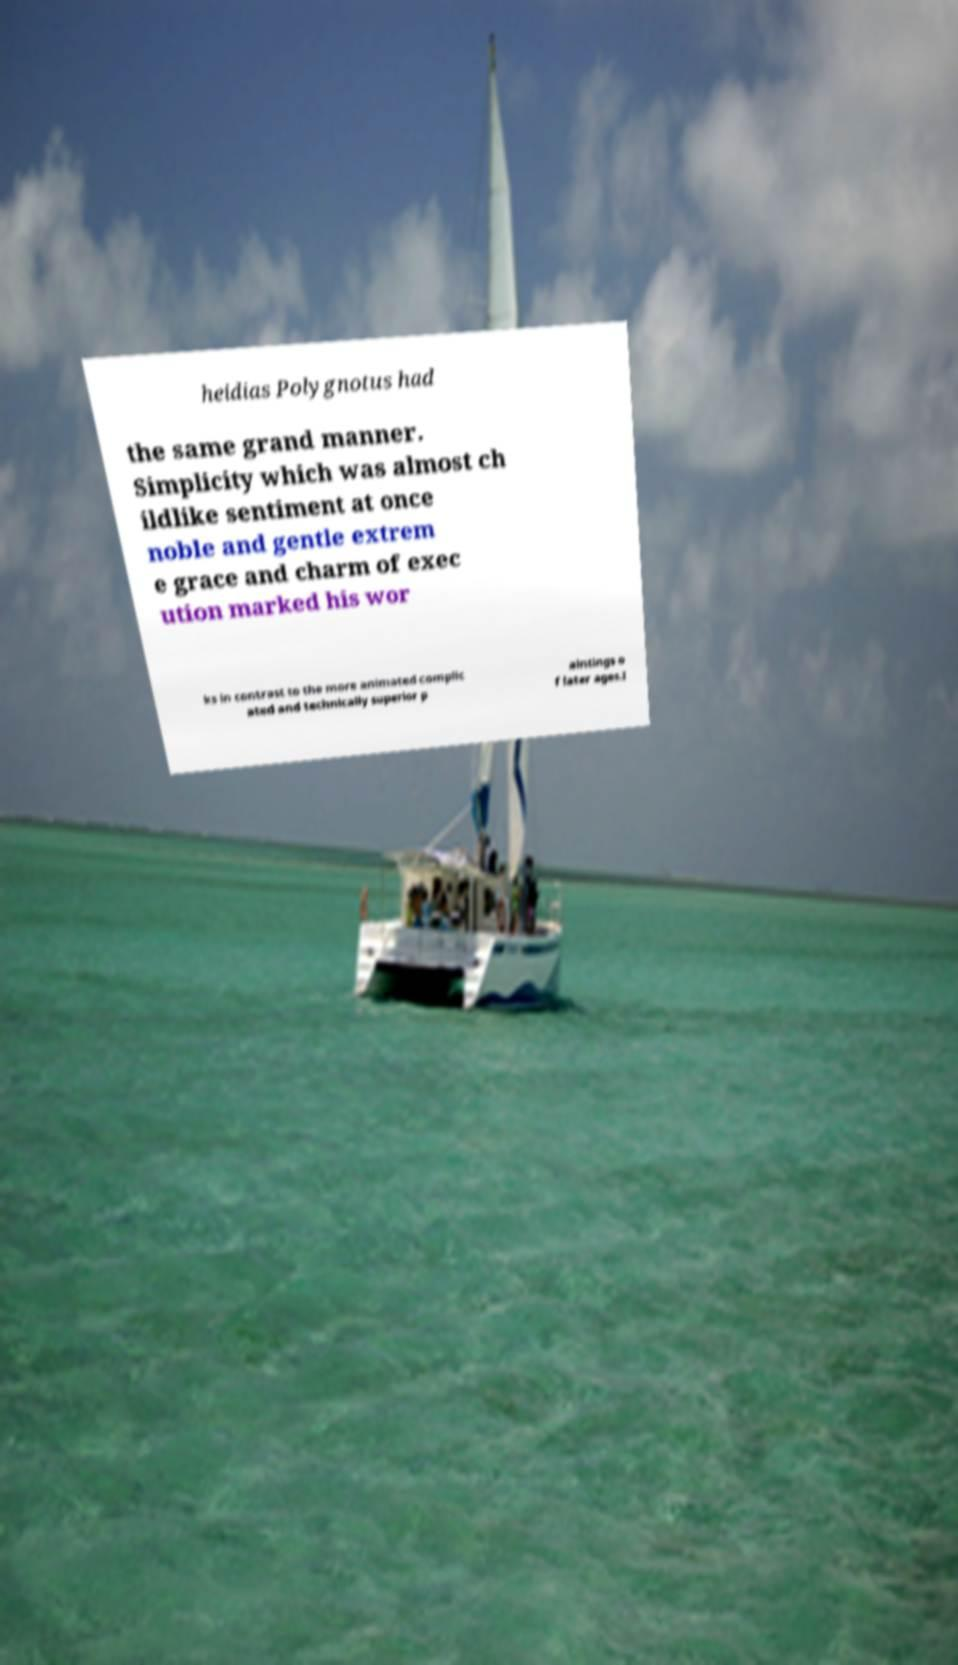Can you accurately transcribe the text from the provided image for me? heidias Polygnotus had the same grand manner. Simplicity which was almost ch ildlike sentiment at once noble and gentle extrem e grace and charm of exec ution marked his wor ks in contrast to the more animated complic ated and technically superior p aintings o f later ages.I 